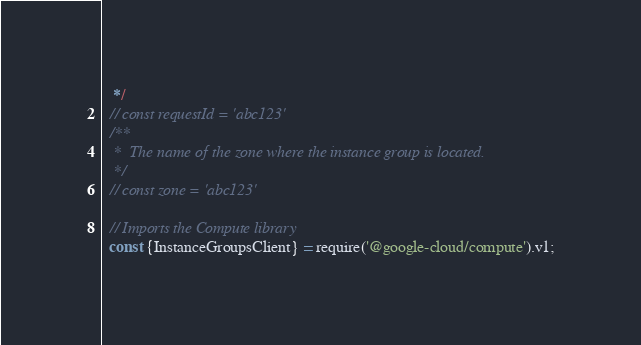<code> <loc_0><loc_0><loc_500><loc_500><_JavaScript_>   */
  // const requestId = 'abc123'
  /**
   *  The name of the zone where the instance group is located.
   */
  // const zone = 'abc123'

  // Imports the Compute library
  const {InstanceGroupsClient} = require('@google-cloud/compute').v1;
</code> 